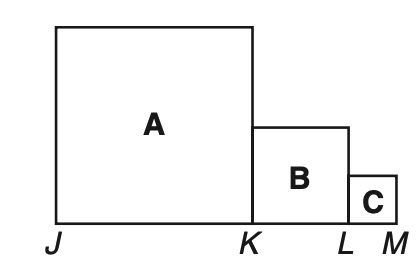Assuming that the smallest square's side is 1 unit, what would the side length of square A be, and how would you calculate the perimeter for the figure then? If the side of the smallest square C is 1 unit, then according to the given ratios, the side of square B would be 2 units because it's twice as large, and the side of square A would be 4 units, quadrupling the side of square C. The perimeter for the figure consists of the outer sides of the squares. Hence the total perimeter would be calculated as the sum of the sides of square A and twice the sum of the sides of squares B and C, which are included in the perimeter calculation. Explicitly, it would be 4*(side of A) + 2*(side of B) + 2*(side of C) = 4*4 + 2*2 + 2*1 = 16 + 4 + 2 = 22 units.  How would you use this relationship to find the value of the smallest side given the total perimeter is actually 66 units? Given the perimeter of 66 units and the ratio of the side lengths, let's denote the side of the smallest square C as 'x'. Therefore, the sides of B and A would be 2x and 4x respectively. We can set up an equation based on the perimeter formula I mentioned earlier: 4*(4x) + 2*(2x) + 2*x equals the total perimeter. This simplifies to 16x + 4x + 2x = 66. Adding the terms together, we have 22x = 66. Dividing both sides by 22 gives us x = 3 units. So the side of the smallest square C would be 3 units. 